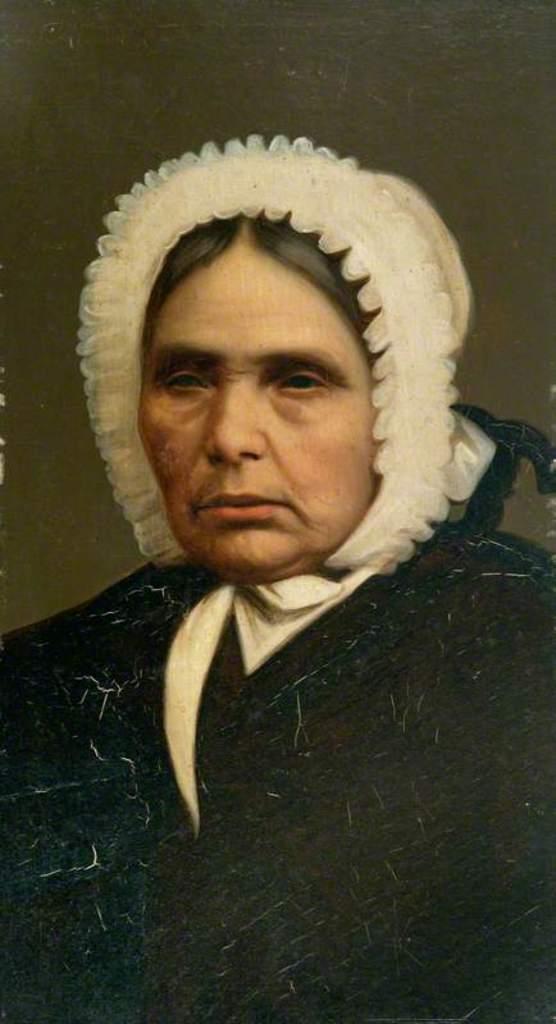Could you give a brief overview of what you see in this image? In the picture we can see a woman wearing a sweater which is black in color and a cap which is white in color. 